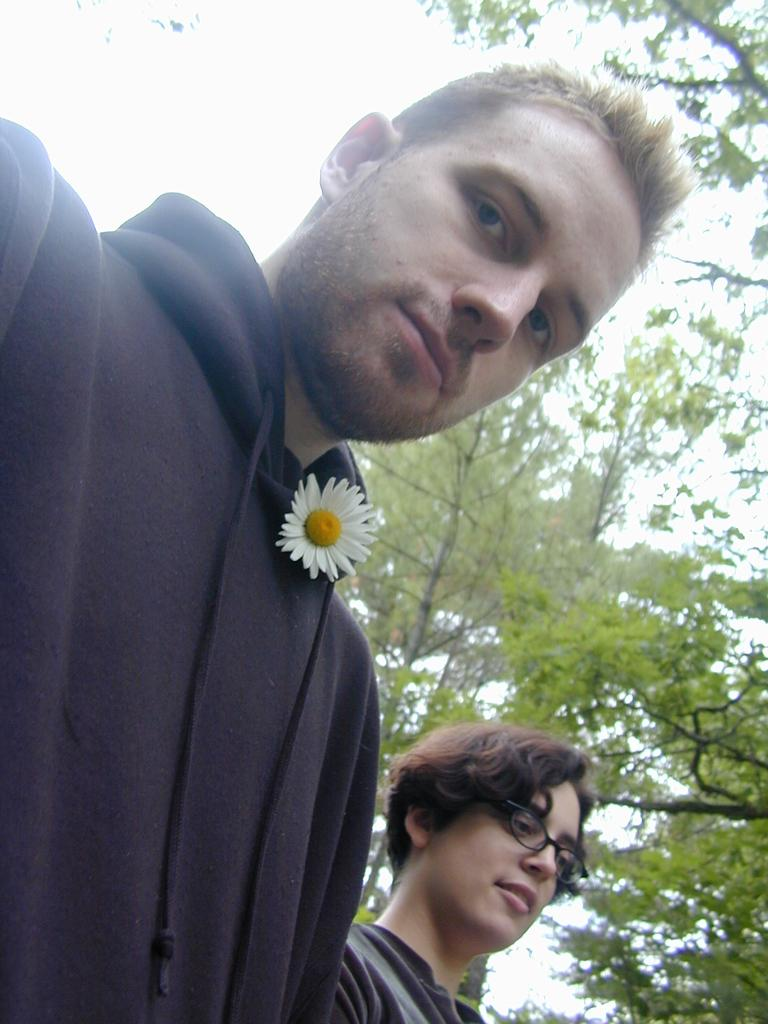How many people are in the image? There are two persons in the image. What can be seen on the jacket of the first person? There is a flower on the jacket of the first person. What type of natural elements can be seen in the background of the image? Branches of trees are visible on the backside of the image. What part of the natural environment is visible in the image? The sky is visible in the image. What type of stamp can be seen on the person's hand in the image? There is: There is no stamp visible on any person's hand in the image. 